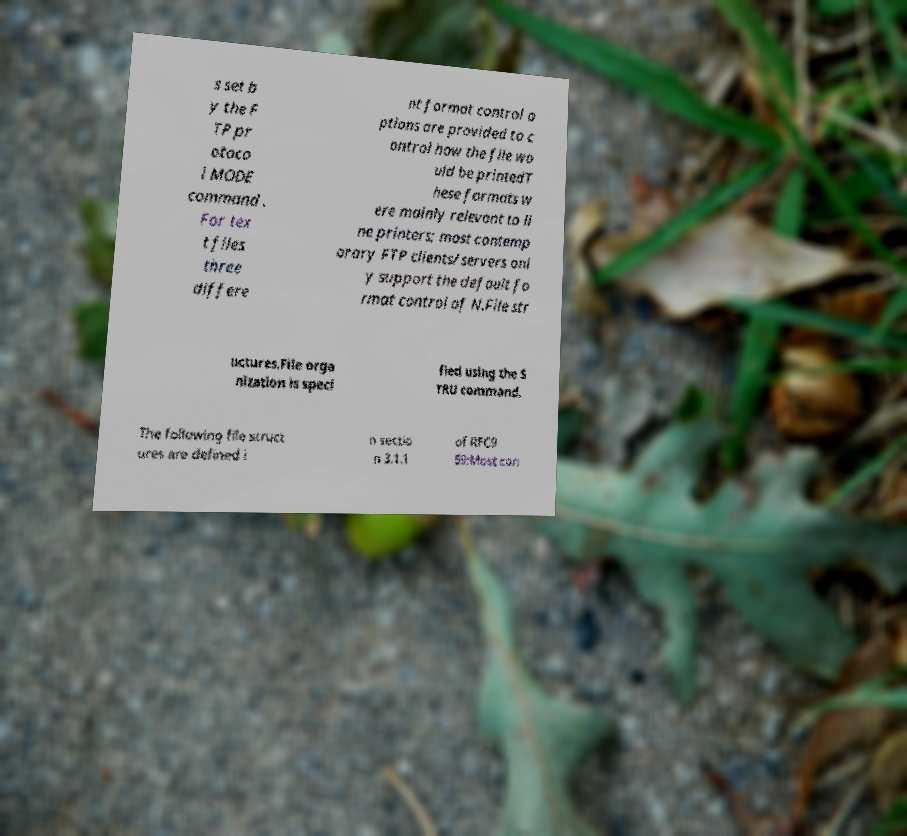What messages or text are displayed in this image? I need them in a readable, typed format. s set b y the F TP pr otoco l MODE command . For tex t files three differe nt format control o ptions are provided to c ontrol how the file wo uld be printedT hese formats w ere mainly relevant to li ne printers; most contemp orary FTP clients/servers onl y support the default fo rmat control of N.File str uctures.File orga nization is speci fied using the S TRU command. The following file struct ures are defined i n sectio n 3.1.1 of RFC9 59:Most con 